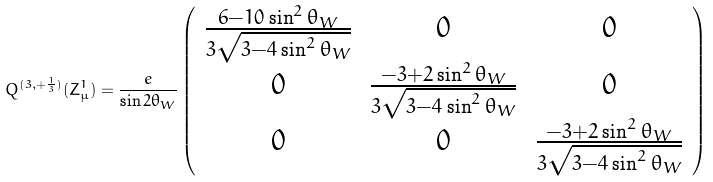<formula> <loc_0><loc_0><loc_500><loc_500>Q ^ { ( 3 , + \frac { 1 } { 3 } ) } ( Z _ { \mu } ^ { 1 } ) = \frac { e } { \sin 2 \theta _ { W } } \left ( \begin{array} { c c c } \frac { 6 - 1 0 \sin ^ { 2 } \theta _ { W } } { 3 \sqrt { 3 - 4 \sin ^ { 2 } \theta _ { W } } } & 0 & 0 \\ 0 & \frac { - 3 + 2 \sin ^ { 2 } \theta _ { W } } { 3 \sqrt { 3 - 4 \sin ^ { 2 } \theta _ { W } } } & 0 \\ 0 & 0 & \frac { - 3 + 2 \sin ^ { 2 } \theta _ { W } } { 3 \sqrt { 3 - 4 \sin ^ { 2 } \theta _ { W } } } \end{array} \right )</formula> 